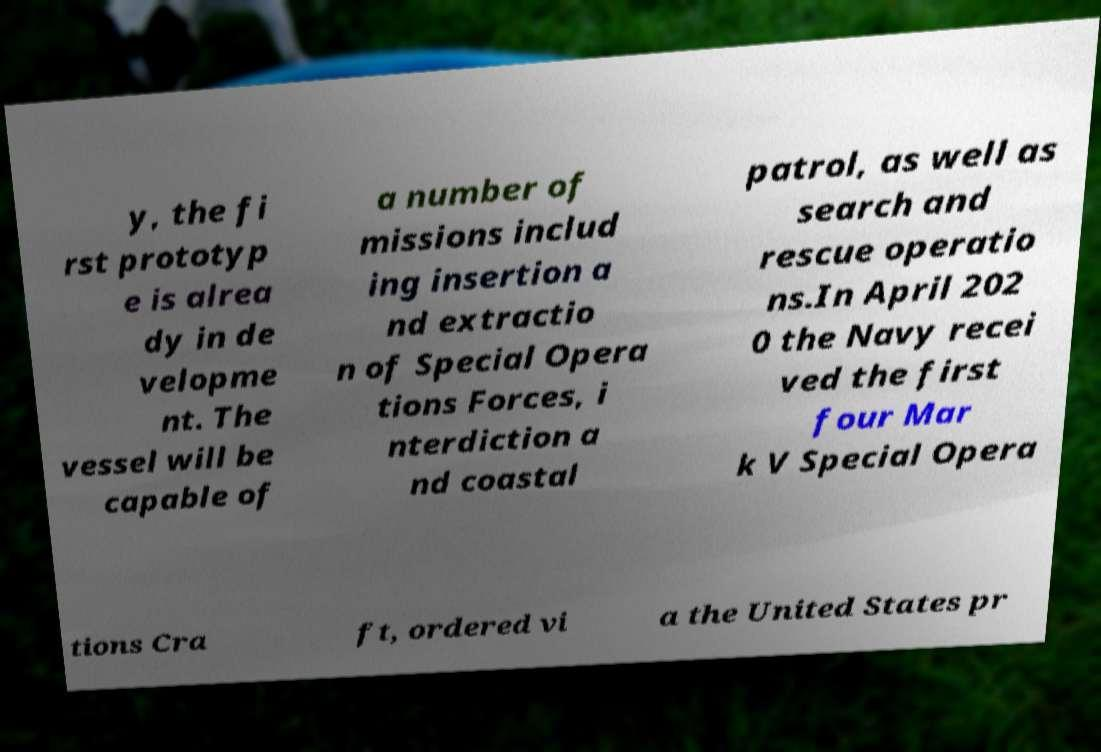For documentation purposes, I need the text within this image transcribed. Could you provide that? y, the fi rst prototyp e is alrea dy in de velopme nt. The vessel will be capable of a number of missions includ ing insertion a nd extractio n of Special Opera tions Forces, i nterdiction a nd coastal patrol, as well as search and rescue operatio ns.In April 202 0 the Navy recei ved the first four Mar k V Special Opera tions Cra ft, ordered vi a the United States pr 